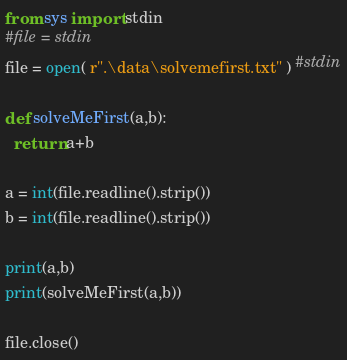Convert code to text. <code><loc_0><loc_0><loc_500><loc_500><_Python_>from sys import stdin
#file = stdin
file = open( r".\data\solvemefirst.txt" ) #stdin

def solveMeFirst(a,b):
  return a+b

a = int(file.readline().strip())
b = int(file.readline().strip())

print(a,b)
print(solveMeFirst(a,b))

file.close()
</code> 